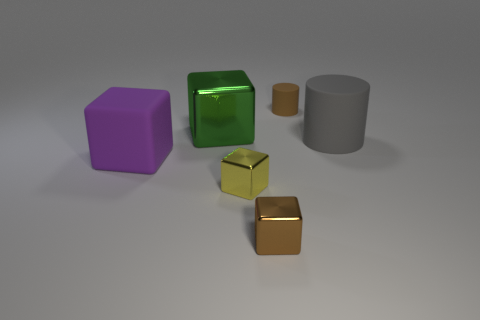Is the material of the large gray cylinder the same as the purple thing?
Ensure brevity in your answer.  Yes. There is a rubber cylinder behind the big green metal cube; is there a small brown matte thing right of it?
Keep it short and to the point. No. What number of blocks are both in front of the big gray cylinder and on the left side of the small yellow thing?
Make the answer very short. 1. There is a large thing on the right side of the big metal cube; what is its shape?
Offer a very short reply. Cylinder. How many brown matte objects have the same size as the purple rubber block?
Your response must be concise. 0. Do the shiny cube in front of the yellow object and the tiny matte object have the same color?
Your response must be concise. Yes. What material is the big object that is both right of the matte cube and left of the big gray thing?
Provide a short and direct response. Metal. Are there more cubes than small gray matte objects?
Give a very brief answer. Yes. The small object that is behind the large block that is in front of the rubber cylinder in front of the green cube is what color?
Your answer should be compact. Brown. Are the tiny brown thing that is left of the small brown matte cylinder and the large purple object made of the same material?
Give a very brief answer. No. 